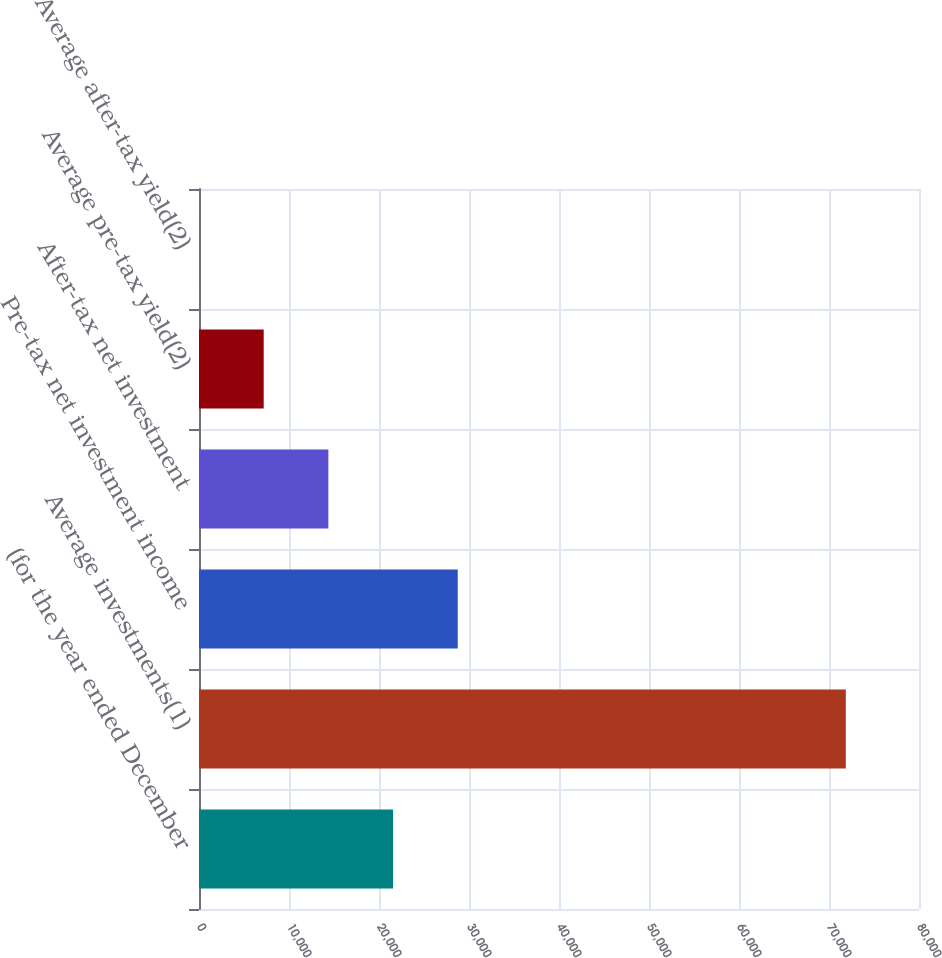<chart> <loc_0><loc_0><loc_500><loc_500><bar_chart><fcel>(for the year ended December<fcel>Average investments(1)<fcel>Pre-tax net investment income<fcel>After-tax net investment<fcel>Average pre-tax yield(2)<fcel>Average after-tax yield(2)<nl><fcel>21561.9<fcel>71867<fcel>28748.4<fcel>14375.5<fcel>7189.04<fcel>2.6<nl></chart> 